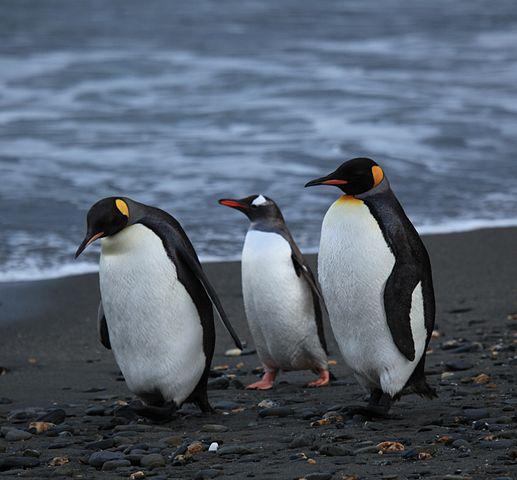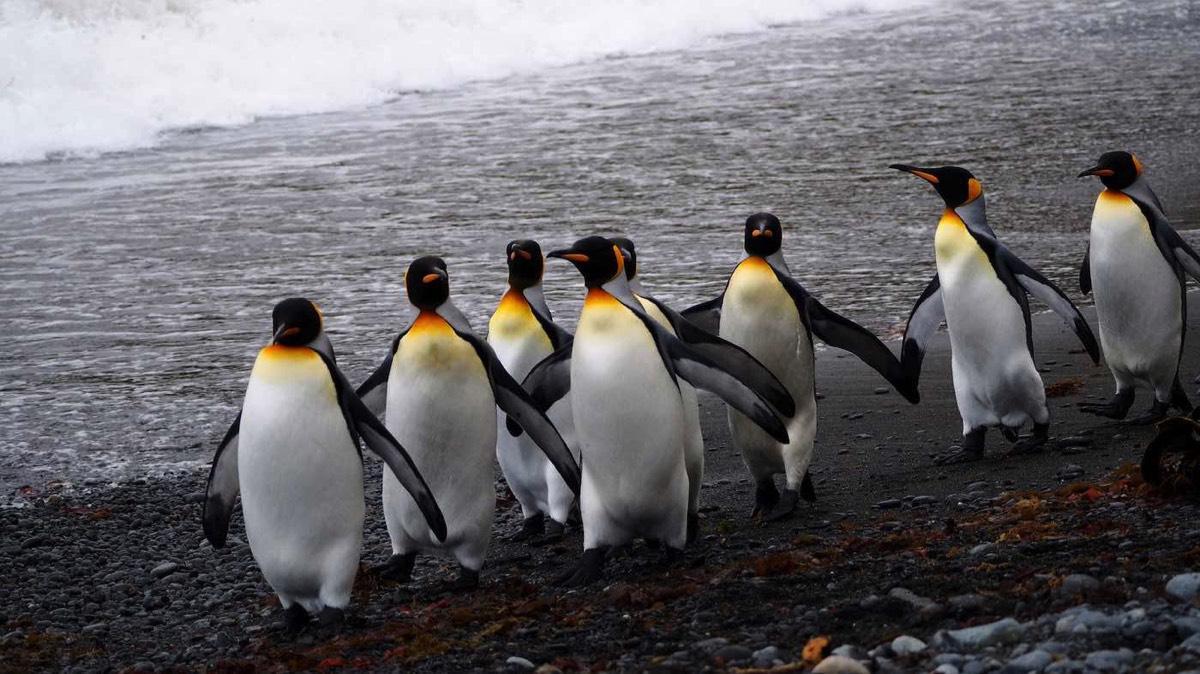The first image is the image on the left, the second image is the image on the right. Assess this claim about the two images: "An image contains no more than two penguins, and includes a penguin with some fuzzy non-sleek feathers.". Correct or not? Answer yes or no. No. The first image is the image on the left, the second image is the image on the right. Analyze the images presented: Is the assertion "There are no more than two penguins in the image on the left." valid? Answer yes or no. No. 